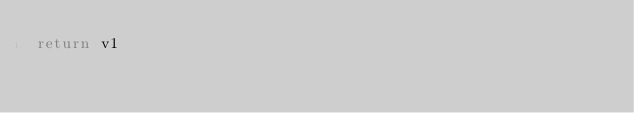<code> <loc_0><loc_0><loc_500><loc_500><_Lua_>return v1
</code> 